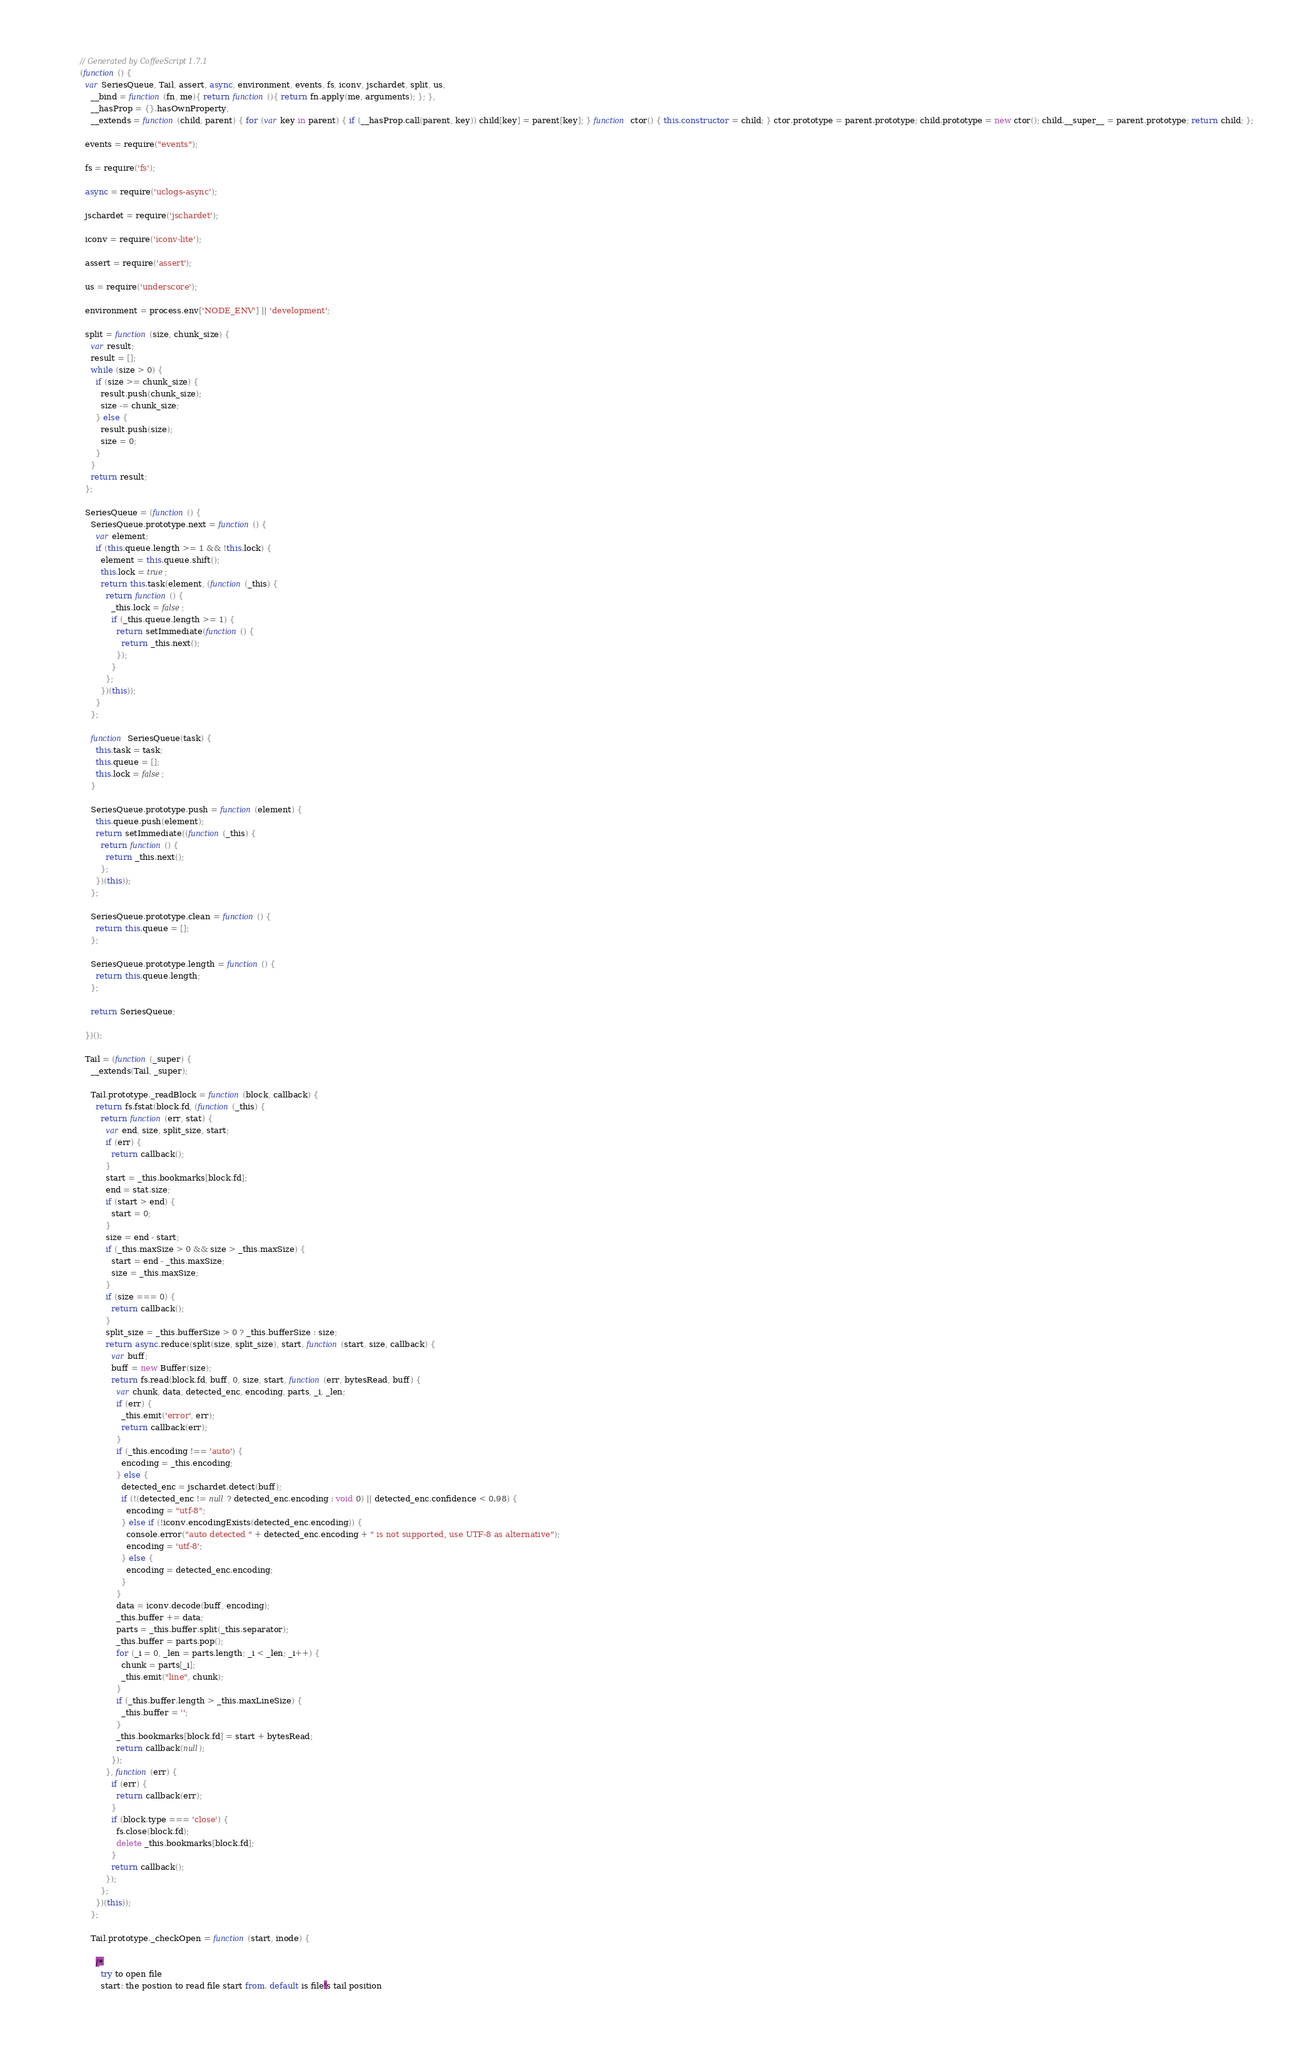Convert code to text. <code><loc_0><loc_0><loc_500><loc_500><_JavaScript_>// Generated by CoffeeScript 1.7.1
(function() {
  var SeriesQueue, Tail, assert, async, environment, events, fs, iconv, jschardet, split, us,
    __bind = function(fn, me){ return function(){ return fn.apply(me, arguments); }; },
    __hasProp = {}.hasOwnProperty,
    __extends = function(child, parent) { for (var key in parent) { if (__hasProp.call(parent, key)) child[key] = parent[key]; } function ctor() { this.constructor = child; } ctor.prototype = parent.prototype; child.prototype = new ctor(); child.__super__ = parent.prototype; return child; };

  events = require("events");

  fs = require('fs');

  async = require('uclogs-async');

  jschardet = require('jschardet');

  iconv = require('iconv-lite');

  assert = require('assert');

  us = require('underscore');

  environment = process.env['NODE_ENV'] || 'development';

  split = function(size, chunk_size) {
    var result;
    result = [];
    while (size > 0) {
      if (size >= chunk_size) {
        result.push(chunk_size);
        size -= chunk_size;
      } else {
        result.push(size);
        size = 0;
      }
    }
    return result;
  };

  SeriesQueue = (function() {
    SeriesQueue.prototype.next = function() {
      var element;
      if (this.queue.length >= 1 && !this.lock) {
        element = this.queue.shift();
        this.lock = true;
        return this.task(element, (function(_this) {
          return function() {
            _this.lock = false;
            if (_this.queue.length >= 1) {
              return setImmediate(function() {
                return _this.next();
              });
            }
          };
        })(this));
      }
    };

    function SeriesQueue(task) {
      this.task = task;
      this.queue = [];
      this.lock = false;
    }

    SeriesQueue.prototype.push = function(element) {
      this.queue.push(element);
      return setImmediate((function(_this) {
        return function() {
          return _this.next();
        };
      })(this));
    };

    SeriesQueue.prototype.clean = function() {
      return this.queue = [];
    };

    SeriesQueue.prototype.length = function() {
      return this.queue.length;
    };

    return SeriesQueue;

  })();

  Tail = (function(_super) {
    __extends(Tail, _super);

    Tail.prototype._readBlock = function(block, callback) {
      return fs.fstat(block.fd, (function(_this) {
        return function(err, stat) {
          var end, size, split_size, start;
          if (err) {
            return callback();
          }
          start = _this.bookmarks[block.fd];
          end = stat.size;
          if (start > end) {
            start = 0;
          }
          size = end - start;
          if (_this.maxSize > 0 && size > _this.maxSize) {
            start = end - _this.maxSize;
            size = _this.maxSize;
          }
          if (size === 0) {
            return callback();
          }
          split_size = _this.bufferSize > 0 ? _this.bufferSize : size;
          return async.reduce(split(size, split_size), start, function(start, size, callback) {
            var buff;
            buff = new Buffer(size);
            return fs.read(block.fd, buff, 0, size, start, function(err, bytesRead, buff) {
              var chunk, data, detected_enc, encoding, parts, _i, _len;
              if (err) {
                _this.emit('error', err);
                return callback(err);
              }
              if (_this.encoding !== 'auto') {
                encoding = _this.encoding;
              } else {
                detected_enc = jschardet.detect(buff);
                if (!(detected_enc != null ? detected_enc.encoding : void 0) || detected_enc.confidence < 0.98) {
                  encoding = "utf-8";
                } else if (!iconv.encodingExists(detected_enc.encoding)) {
                  console.error("auto detected " + detected_enc.encoding + " is not supported, use UTF-8 as alternative");
                  encoding = 'utf-8';
                } else {
                  encoding = detected_enc.encoding;
                }
              }
              data = iconv.decode(buff, encoding);
              _this.buffer += data;
              parts = _this.buffer.split(_this.separator);
              _this.buffer = parts.pop();
              for (_i = 0, _len = parts.length; _i < _len; _i++) {
                chunk = parts[_i];
                _this.emit("line", chunk);
              }
              if (_this.buffer.length > _this.maxLineSize) {
                _this.buffer = '';
              }
              _this.bookmarks[block.fd] = start + bytesRead;
              return callback(null);
            });
          }, function(err) {
            if (err) {
              return callback(err);
            }
            if (block.type === 'close') {
              fs.close(block.fd);
              delete _this.bookmarks[block.fd];
            }
            return callback();
          });
        };
      })(this));
    };

    Tail.prototype._checkOpen = function(start, inode) {

      /*
        try to open file
        start: the postion to read file start from. default is file's tail position</code> 